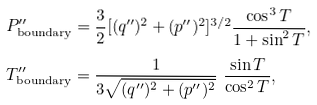Convert formula to latex. <formula><loc_0><loc_0><loc_500><loc_500>P ^ { \prime \prime } _ { \text {boundary} } & = \frac { 3 } { 2 } [ ( q ^ { \prime \prime } ) ^ { 2 } + ( p ^ { \prime \prime } ) ^ { 2 } ] ^ { 3 / 2 } \frac { \cos ^ { 3 } T } { 1 + \sin ^ { 2 } T } , \\ T ^ { \prime \prime } _ { \text {boundary} } & = \frac { 1 } { 3 \sqrt { ( q ^ { \prime \prime } ) ^ { 2 } + ( p ^ { \prime \prime } ) ^ { 2 } } } \ \frac { \sin T } { \cos ^ { 2 } T } ,</formula> 